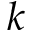Convert formula to latex. <formula><loc_0><loc_0><loc_500><loc_500>k</formula> 